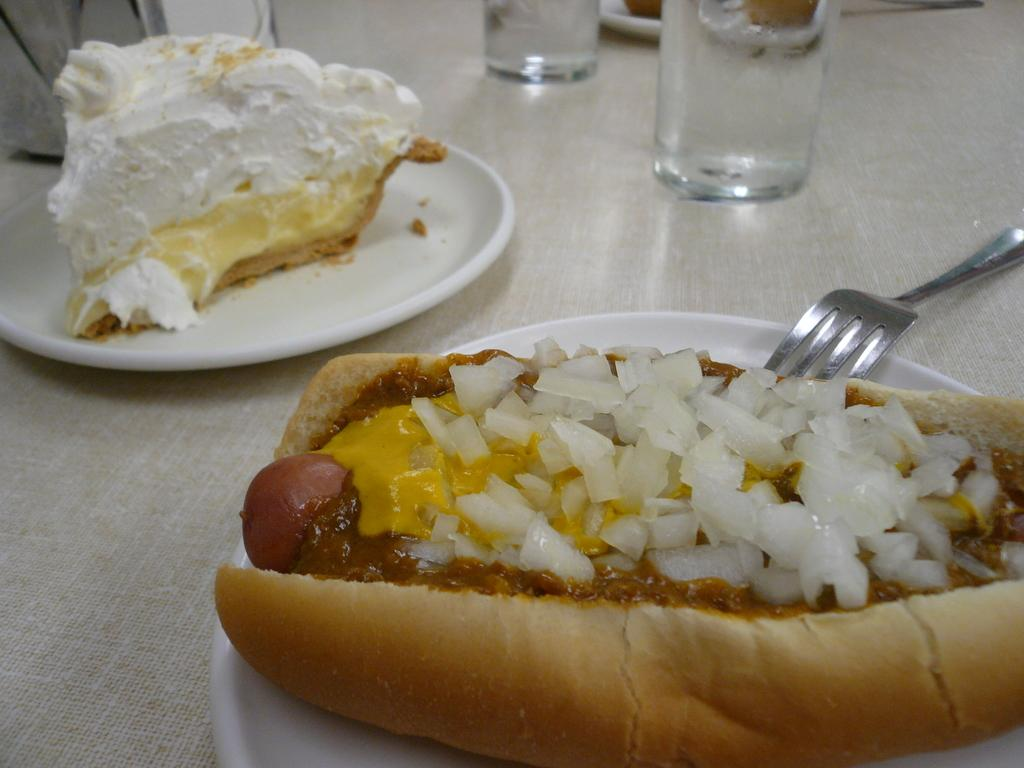What piece of furniture is present in the image? There is a table in the image. What items are placed on the table? There are plates, glasses, forks, a cake, and a hot dog on the table. What type of food can be seen on the table? There is a cake and a hot dog on the table. Where is the fan located in the image? There is no fan present in the image. What type of oatmeal is being served on the table? There is no oatmeal present in the image; it features a cake and a hot dog. 